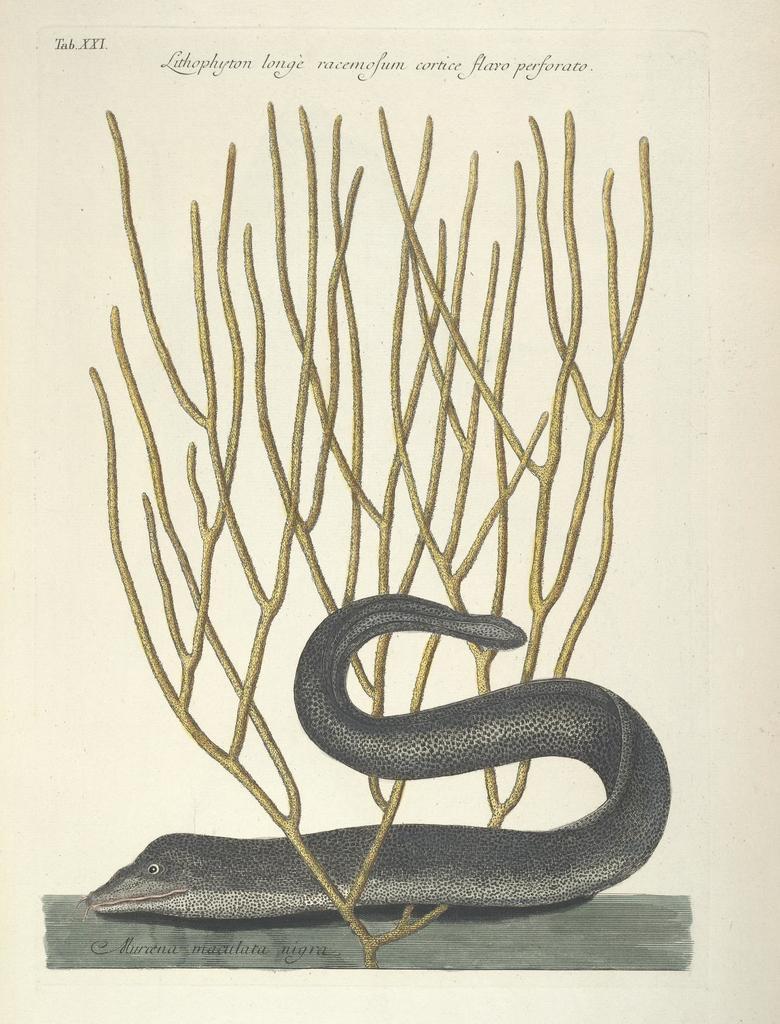Could you give a brief overview of what you see in this image? This picture might be a painting in a book. In this image, we can see a painting of snake and some text is written on it. 